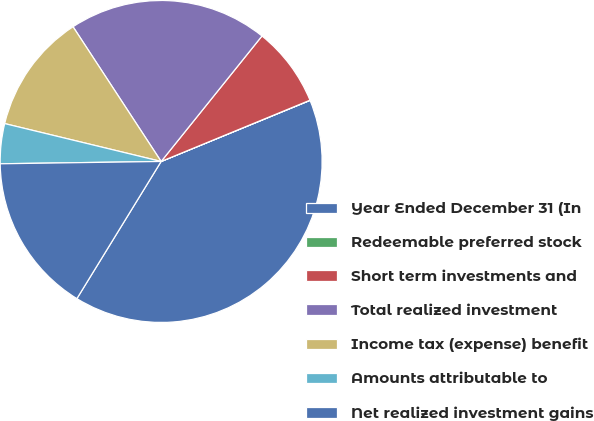Convert chart. <chart><loc_0><loc_0><loc_500><loc_500><pie_chart><fcel>Year Ended December 31 (In<fcel>Redeemable preferred stock<fcel>Short term investments and<fcel>Total realized investment<fcel>Income tax (expense) benefit<fcel>Amounts attributable to<fcel>Net realized investment gains<nl><fcel>39.96%<fcel>0.02%<fcel>8.01%<fcel>19.99%<fcel>12.0%<fcel>4.01%<fcel>16.0%<nl></chart> 